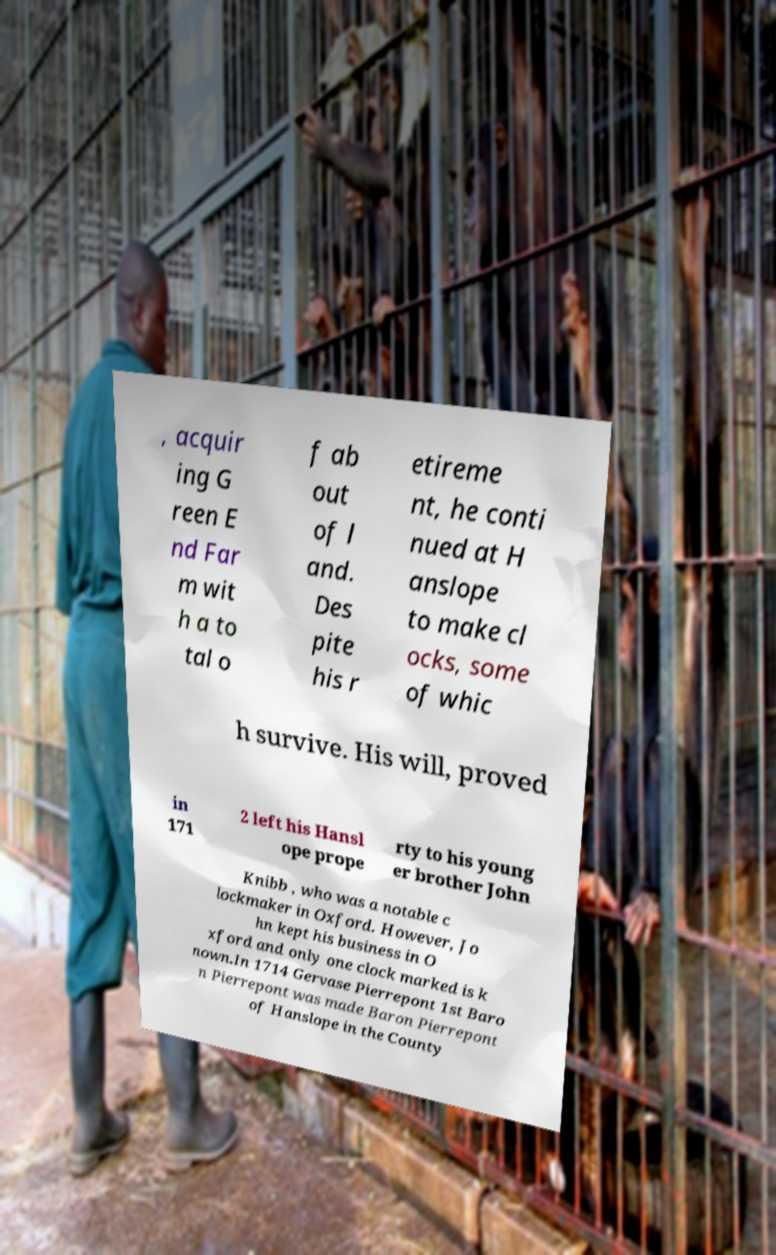Could you extract and type out the text from this image? , acquir ing G reen E nd Far m wit h a to tal o f ab out of l and. Des pite his r etireme nt, he conti nued at H anslope to make cl ocks, some of whic h survive. His will, proved in 171 2 left his Hansl ope prope rty to his young er brother John Knibb , who was a notable c lockmaker in Oxford. However, Jo hn kept his business in O xford and only one clock marked is k nown.In 1714 Gervase Pierrepont 1st Baro n Pierrepont was made Baron Pierrepont of Hanslope in the County 